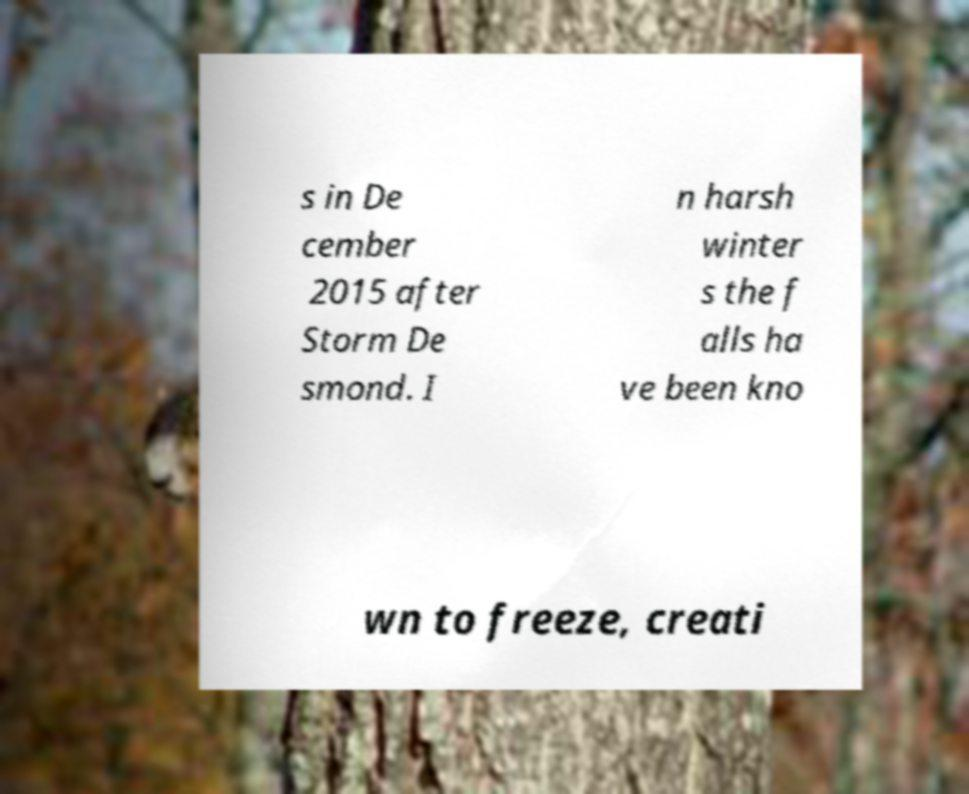There's text embedded in this image that I need extracted. Can you transcribe it verbatim? s in De cember 2015 after Storm De smond. I n harsh winter s the f alls ha ve been kno wn to freeze, creati 